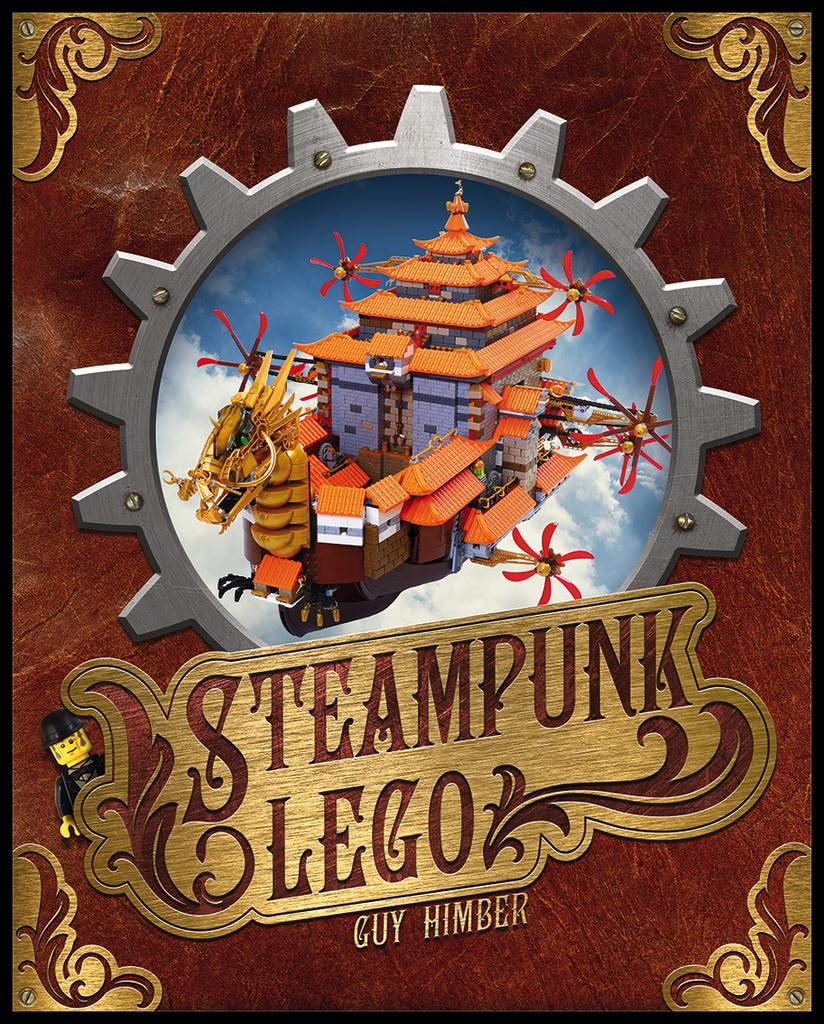<image>
Write a terse but informative summary of the picture. A cover for a Steampunk Lego set from Guy Himber 